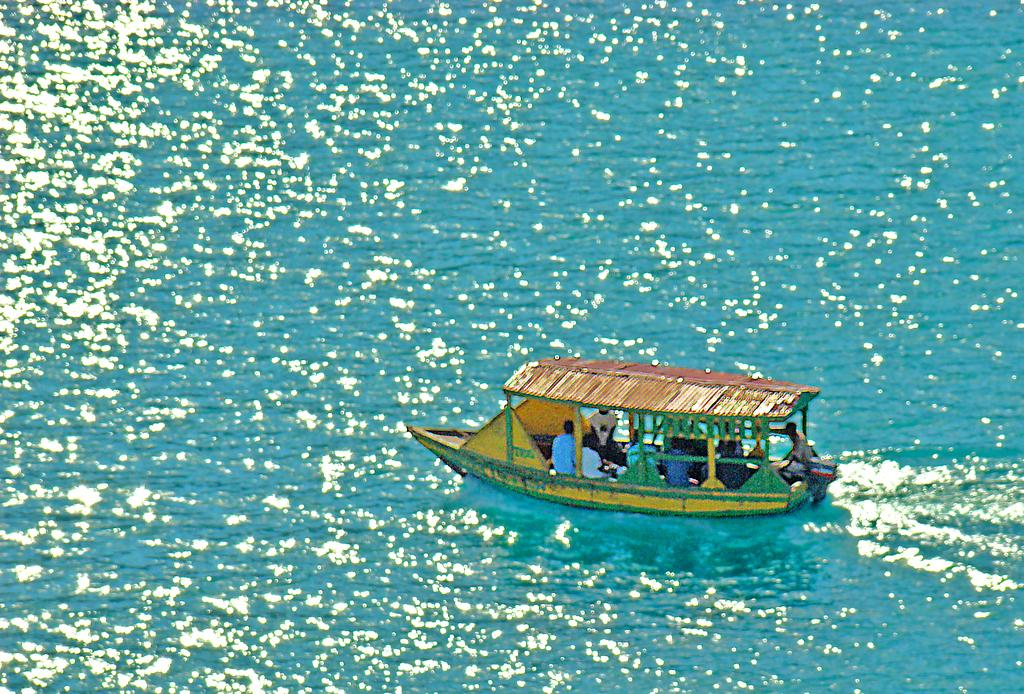What are the people in the image doing? The persons in the image are sitting in a boat. Where is the boat located? The boat is on the water. What feature does the boat have? The boat has a roof. What type of cream can be seen on the person's toe in the image? There is no cream or person's toe visible in the image; it features a boat with a roof and persons sitting inside. 